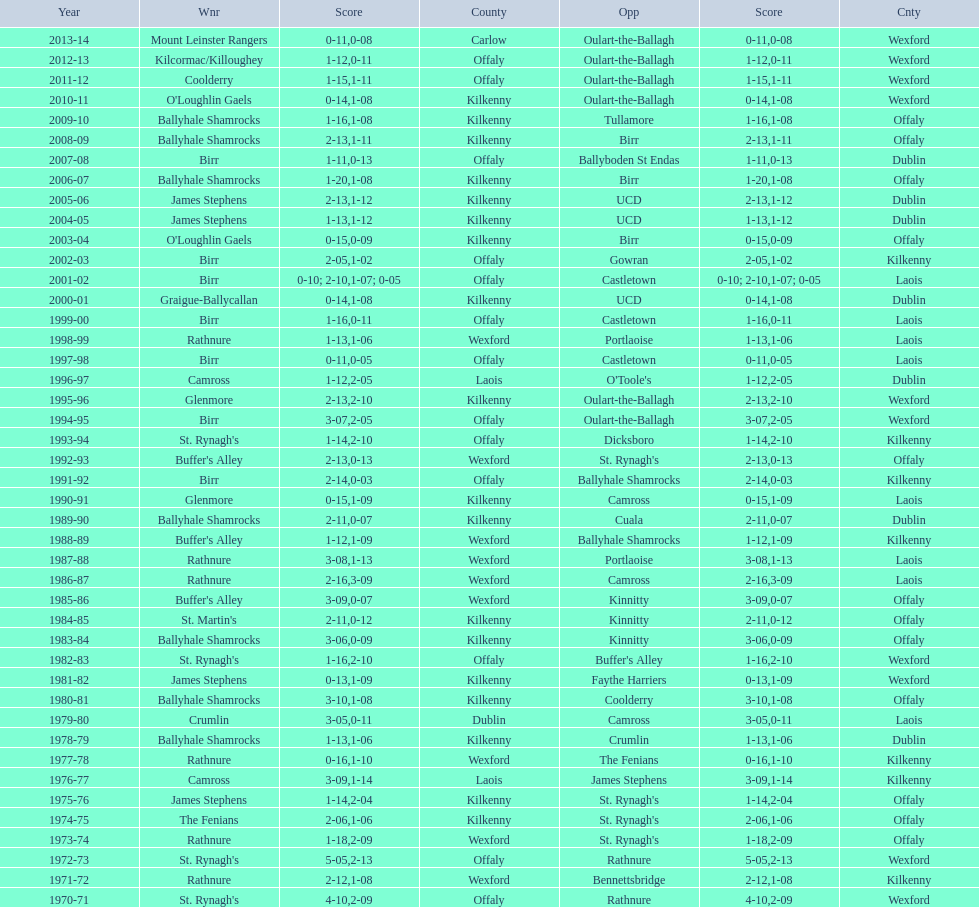Which country had the most wins? Kilkenny. 